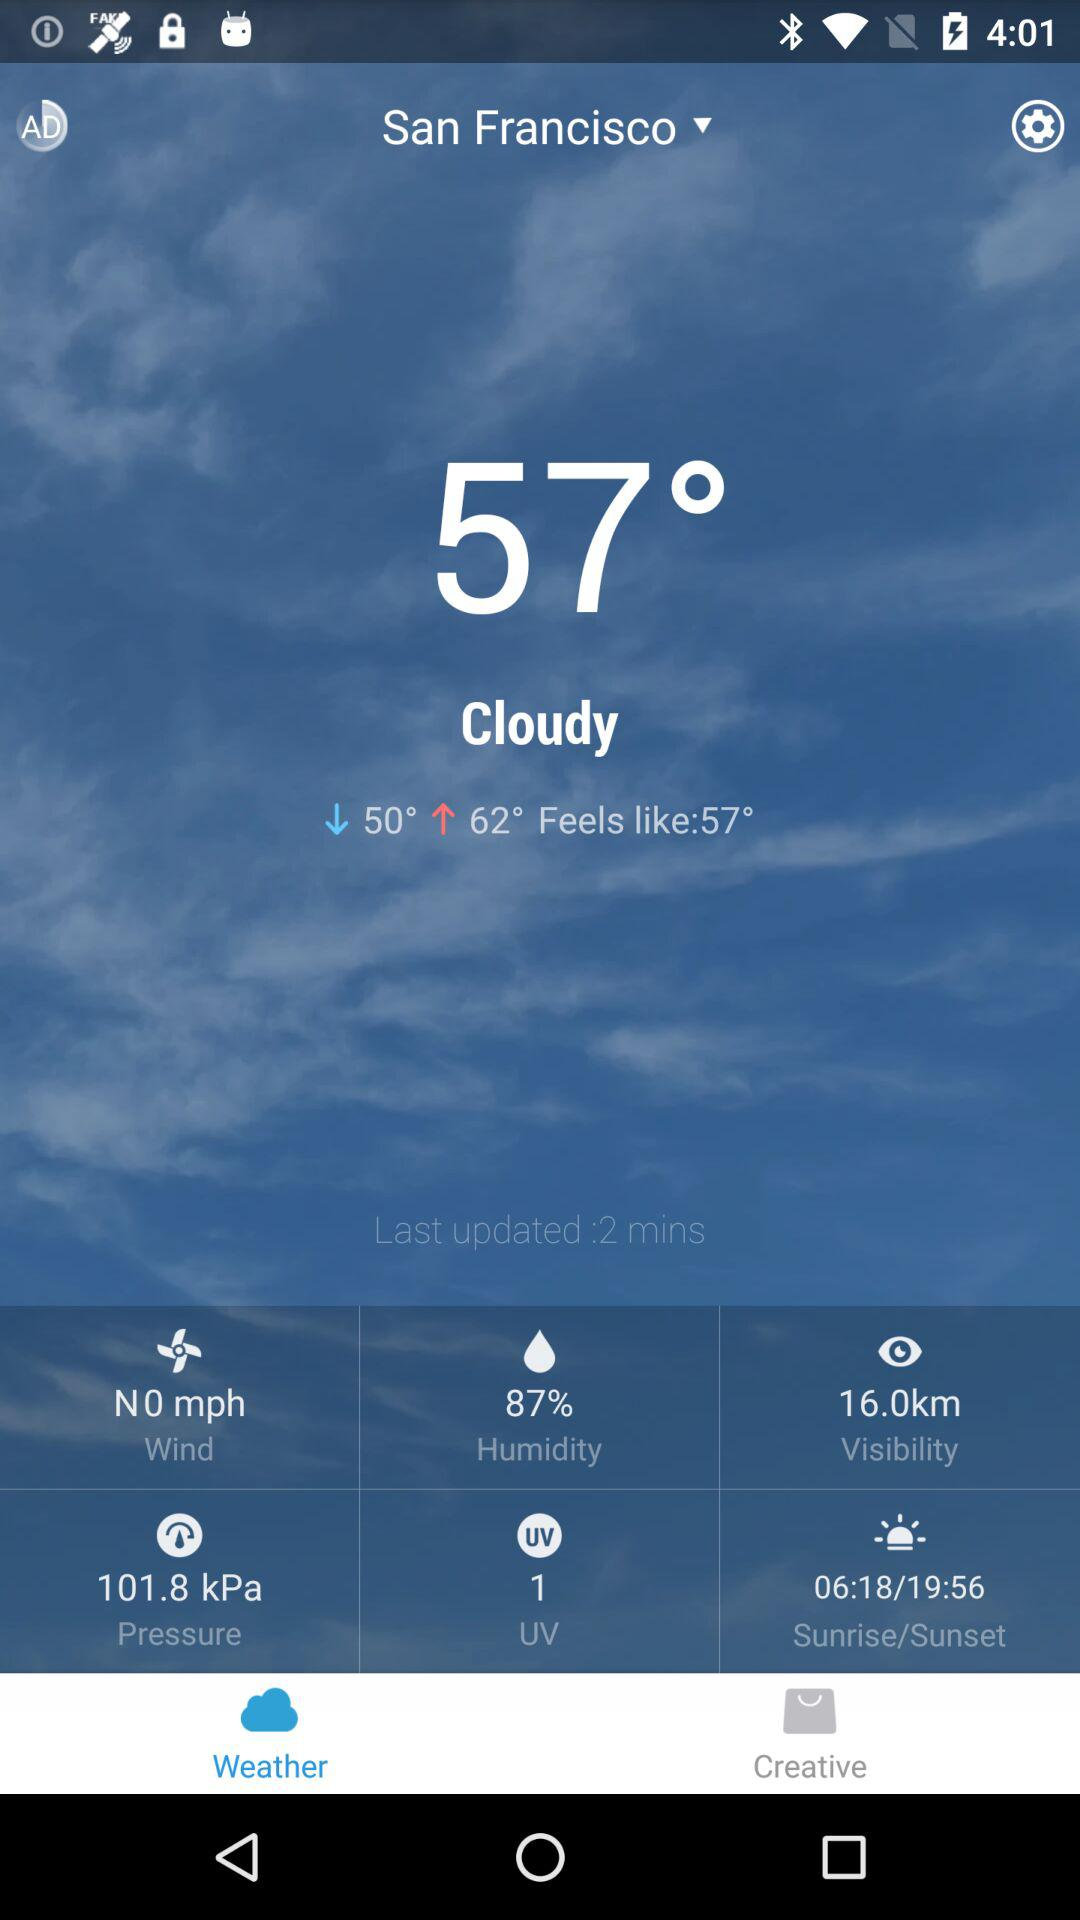What is the humidity percentage?
Answer the question using a single word or phrase. 87% 